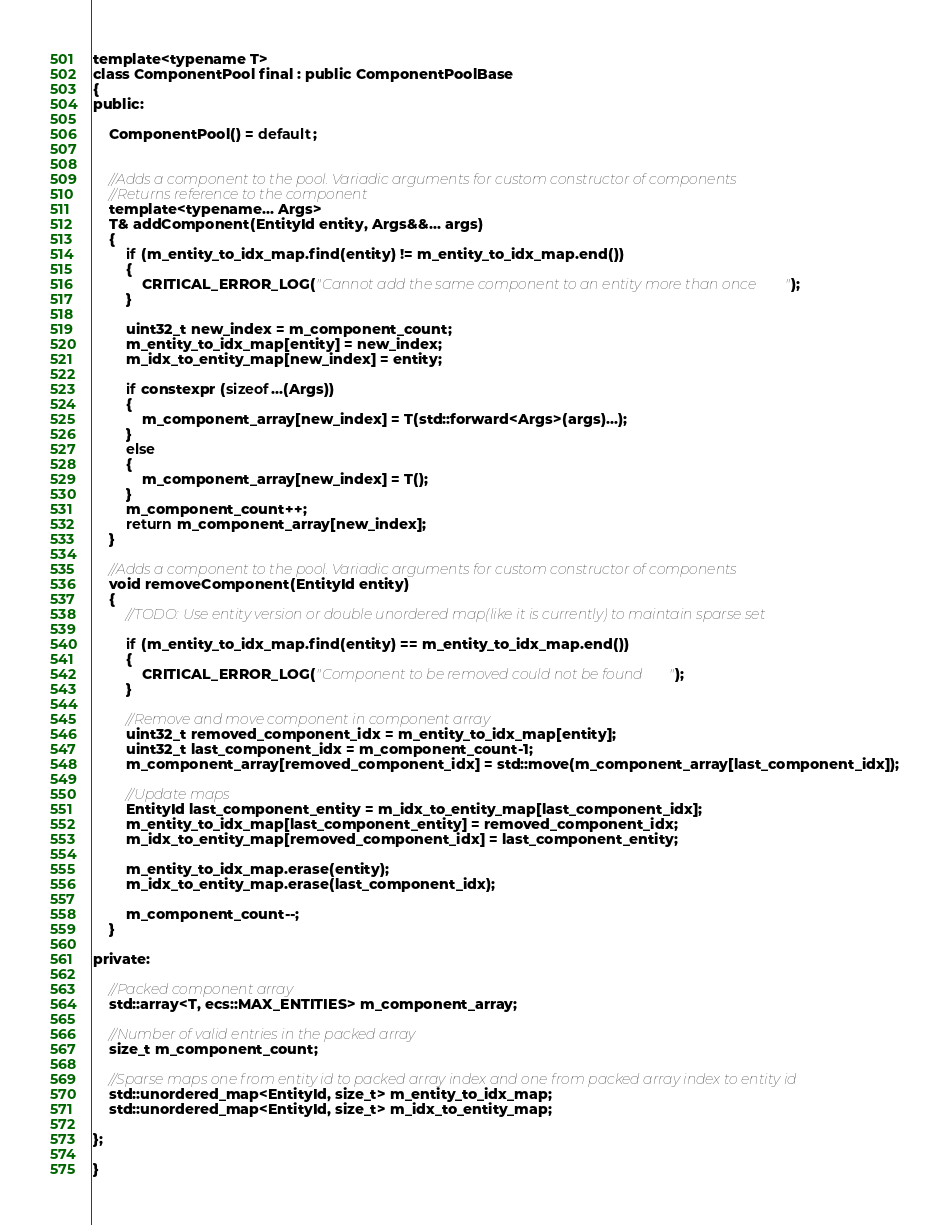<code> <loc_0><loc_0><loc_500><loc_500><_C_>template<typename T>
class ComponentPool final : public ComponentPoolBase
{
public:

	ComponentPool() = default;


	//Adds a component to the pool. Variadic arguments for custom constructor of components
	//Returns reference to the component
	template<typename... Args>
	T& addComponent(EntityId entity, Args&&... args)
	{
		if (m_entity_to_idx_map.find(entity) != m_entity_to_idx_map.end())
		{
			CRITICAL_ERROR_LOG("Cannot add the same component to an entity more than once");
		}

		uint32_t new_index = m_component_count;
		m_entity_to_idx_map[entity] = new_index;
		m_idx_to_entity_map[new_index] = entity;

		if constexpr (sizeof...(Args))
		{
			m_component_array[new_index] = T(std::forward<Args>(args)...);
		}
		else
		{
			m_component_array[new_index] = T();
		}
		m_component_count++;
		return m_component_array[new_index];
	}

	//Adds a component to the pool. Variadic arguments for custom constructor of components
	void removeComponent(EntityId entity)
	{
		//TODO: Use entity version or double unordered map(like it is currently) to maintain sparse set
		
		if (m_entity_to_idx_map.find(entity) == m_entity_to_idx_map.end())
		{
			CRITICAL_ERROR_LOG("Component to be removed could not be found");
		}

		//Remove and move component in component array
		uint32_t removed_component_idx = m_entity_to_idx_map[entity];
		uint32_t last_component_idx = m_component_count-1;
		m_component_array[removed_component_idx] = std::move(m_component_array[last_component_idx]);

		//Update maps
		EntityId last_component_entity = m_idx_to_entity_map[last_component_idx];
		m_entity_to_idx_map[last_component_entity] = removed_component_idx;
		m_idx_to_entity_map[removed_component_idx] = last_component_entity;

		m_entity_to_idx_map.erase(entity);
		m_idx_to_entity_map.erase(last_component_idx);

		m_component_count--;
	}

private:

	//Packed component array
	std::array<T, ecs::MAX_ENTITIES> m_component_array;

	//Number of valid entries in the packed array
	size_t m_component_count;

	//Sparse maps one from entity id to packed array index and one from packed array index to entity id
	std::unordered_map<EntityId, size_t> m_entity_to_idx_map;
	std::unordered_map<EntityId, size_t> m_idx_to_entity_map;

};

}</code> 